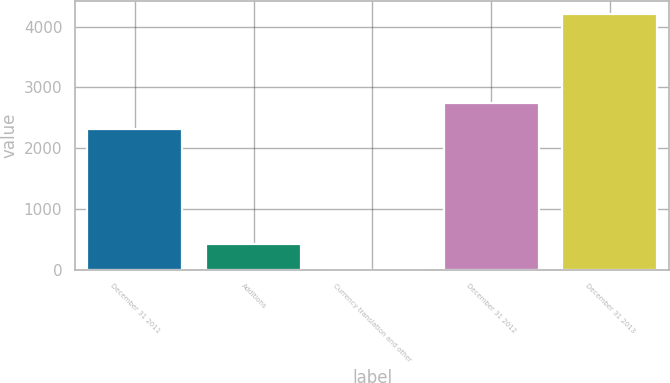<chart> <loc_0><loc_0><loc_500><loc_500><bar_chart><fcel>December 31 2011<fcel>Additions<fcel>Currency translation and other<fcel>December 31 2012<fcel>December 31 2013<nl><fcel>2317<fcel>423.2<fcel>3<fcel>2737.2<fcel>4205<nl></chart> 